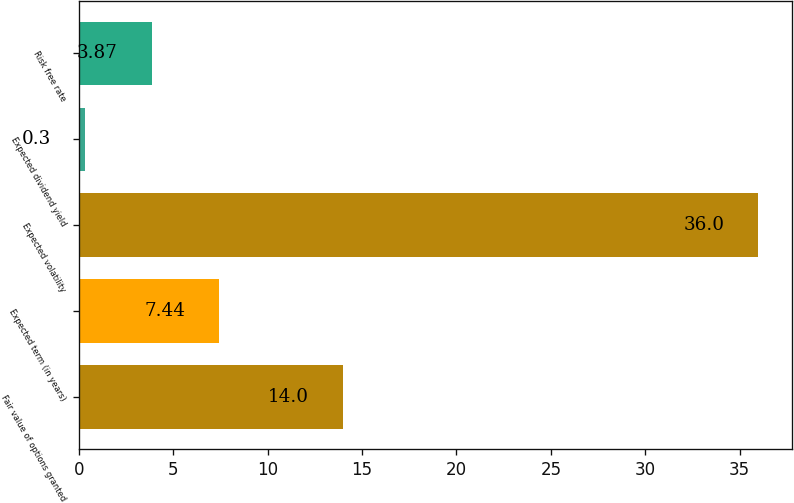<chart> <loc_0><loc_0><loc_500><loc_500><bar_chart><fcel>Fair value of options granted<fcel>Expected term (in years)<fcel>Expected volatility<fcel>Expected dividend yield<fcel>Risk free rate<nl><fcel>14<fcel>7.44<fcel>36<fcel>0.3<fcel>3.87<nl></chart> 